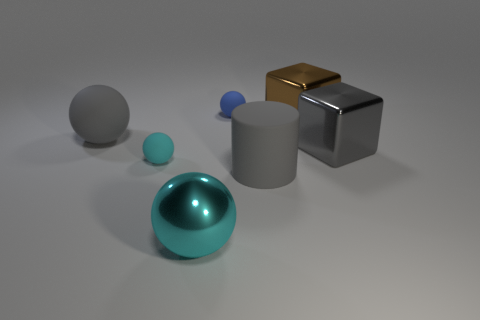Can you describe the lighting and shadows in the image? The lighting in the image seems to be diffused, coming from the upper left side, creating soft-edged shadows that stretch towards the bottom right. These shadows are cast on a neutral gray surface, allowing for the objects' textures and the direction of light to be observed clearly. The smooth objects reflect light intensely at their highlight points, while the more matte surfaces display a subdued brightness. 